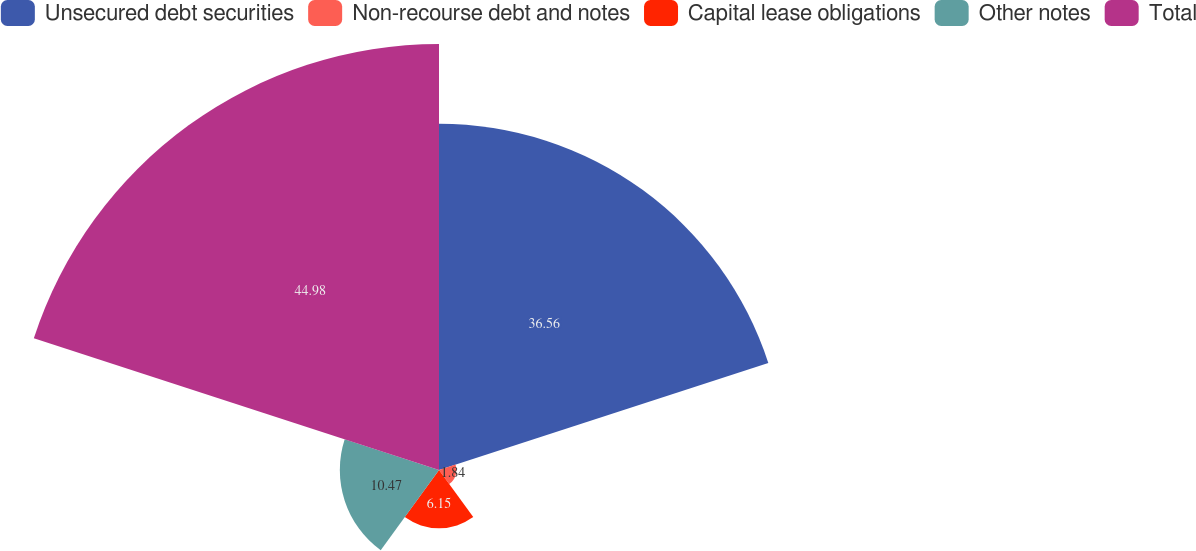<chart> <loc_0><loc_0><loc_500><loc_500><pie_chart><fcel>Unsecured debt securities<fcel>Non-recourse debt and notes<fcel>Capital lease obligations<fcel>Other notes<fcel>Total<nl><fcel>36.56%<fcel>1.84%<fcel>6.15%<fcel>10.47%<fcel>44.98%<nl></chart> 